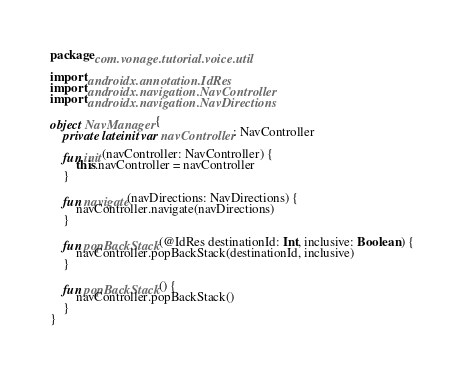<code> <loc_0><loc_0><loc_500><loc_500><_Kotlin_>package com.vonage.tutorial.voice.util

import androidx.annotation.IdRes
import androidx.navigation.NavController
import androidx.navigation.NavDirections

object NavManager {
    private lateinit var navController: NavController

    fun init(navController: NavController) {
        this.navController = navController
    }

    fun navigate(navDirections: NavDirections) {
        navController.navigate(navDirections)
    }

    fun popBackStack(@IdRes destinationId: Int, inclusive: Boolean) {
        navController.popBackStack(destinationId, inclusive)
    }

    fun popBackStack() {
        navController.popBackStack()
    }
}
</code> 